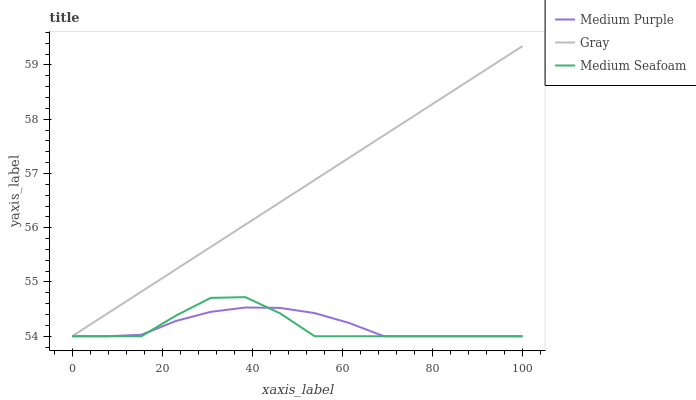Does Medium Seafoam have the minimum area under the curve?
Answer yes or no. Yes. Does Gray have the maximum area under the curve?
Answer yes or no. Yes. Does Gray have the minimum area under the curve?
Answer yes or no. No. Does Medium Seafoam have the maximum area under the curve?
Answer yes or no. No. Is Gray the smoothest?
Answer yes or no. Yes. Is Medium Seafoam the roughest?
Answer yes or no. Yes. Is Medium Seafoam the smoothest?
Answer yes or no. No. Is Gray the roughest?
Answer yes or no. No. Does Medium Purple have the lowest value?
Answer yes or no. Yes. Does Gray have the highest value?
Answer yes or no. Yes. Does Medium Seafoam have the highest value?
Answer yes or no. No. Does Medium Seafoam intersect Gray?
Answer yes or no. Yes. Is Medium Seafoam less than Gray?
Answer yes or no. No. Is Medium Seafoam greater than Gray?
Answer yes or no. No. 